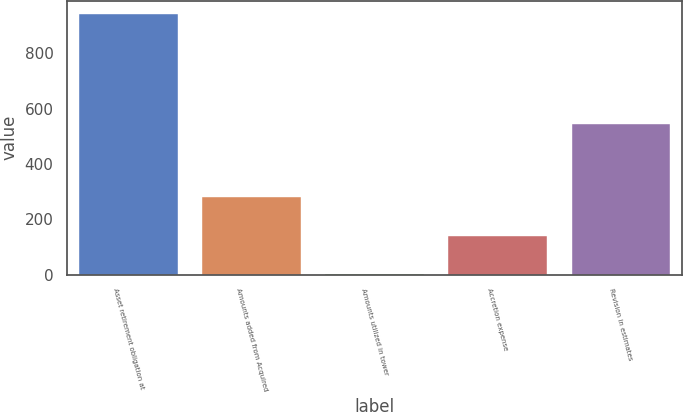<chart> <loc_0><loc_0><loc_500><loc_500><bar_chart><fcel>Asset retirement obligation at<fcel>Amounts added from Acquired<fcel>Amounts utilized in tower<fcel>Accretion expense<fcel>Revision in estimates<nl><fcel>942<fcel>281.6<fcel>1<fcel>141.3<fcel>544<nl></chart> 